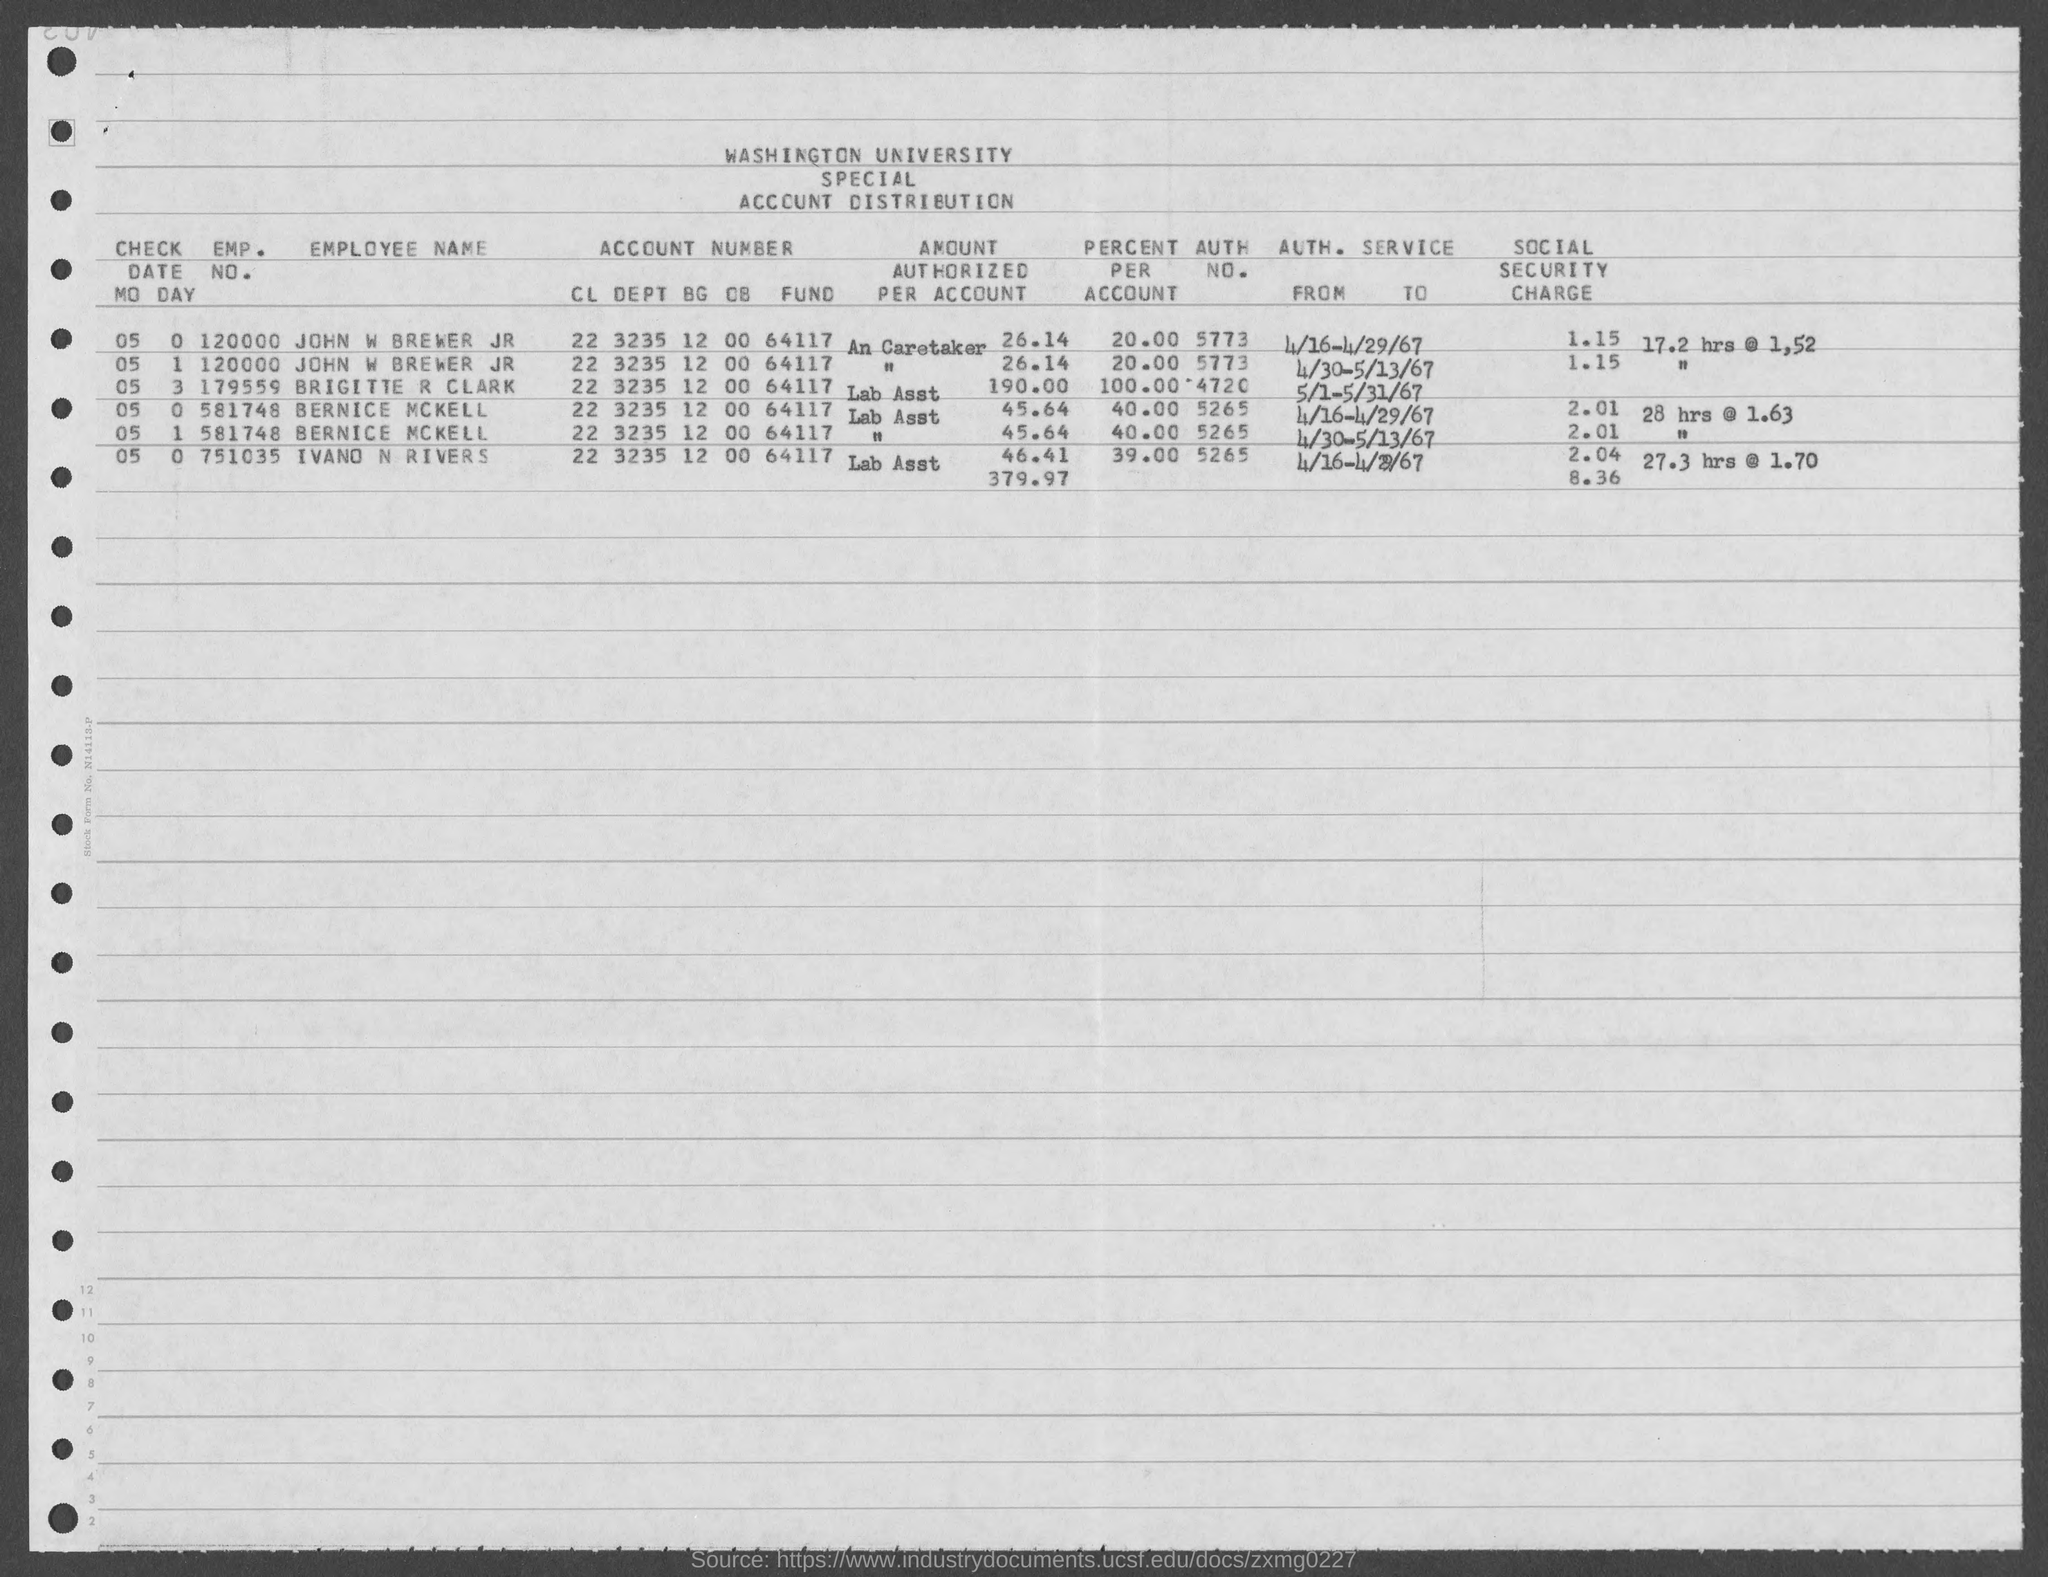What is the name of the university mentioned in the given form ?
Give a very brief answer. Washington university. What is the account number of john w brewer jr as mentioned in the given page ?
Offer a very short reply. 22 3235 12 00 64117. What is the emp. no. of bernice mckell as mentioned in the given form ?
Provide a succinct answer. 581748. What is the emp. no. of john w brewer as mentioned in the given page ?
Offer a terse response. 120000. What is the emp. no. of ivand n rivers as mentioned in the given page ?
Offer a very short reply. 751035. 